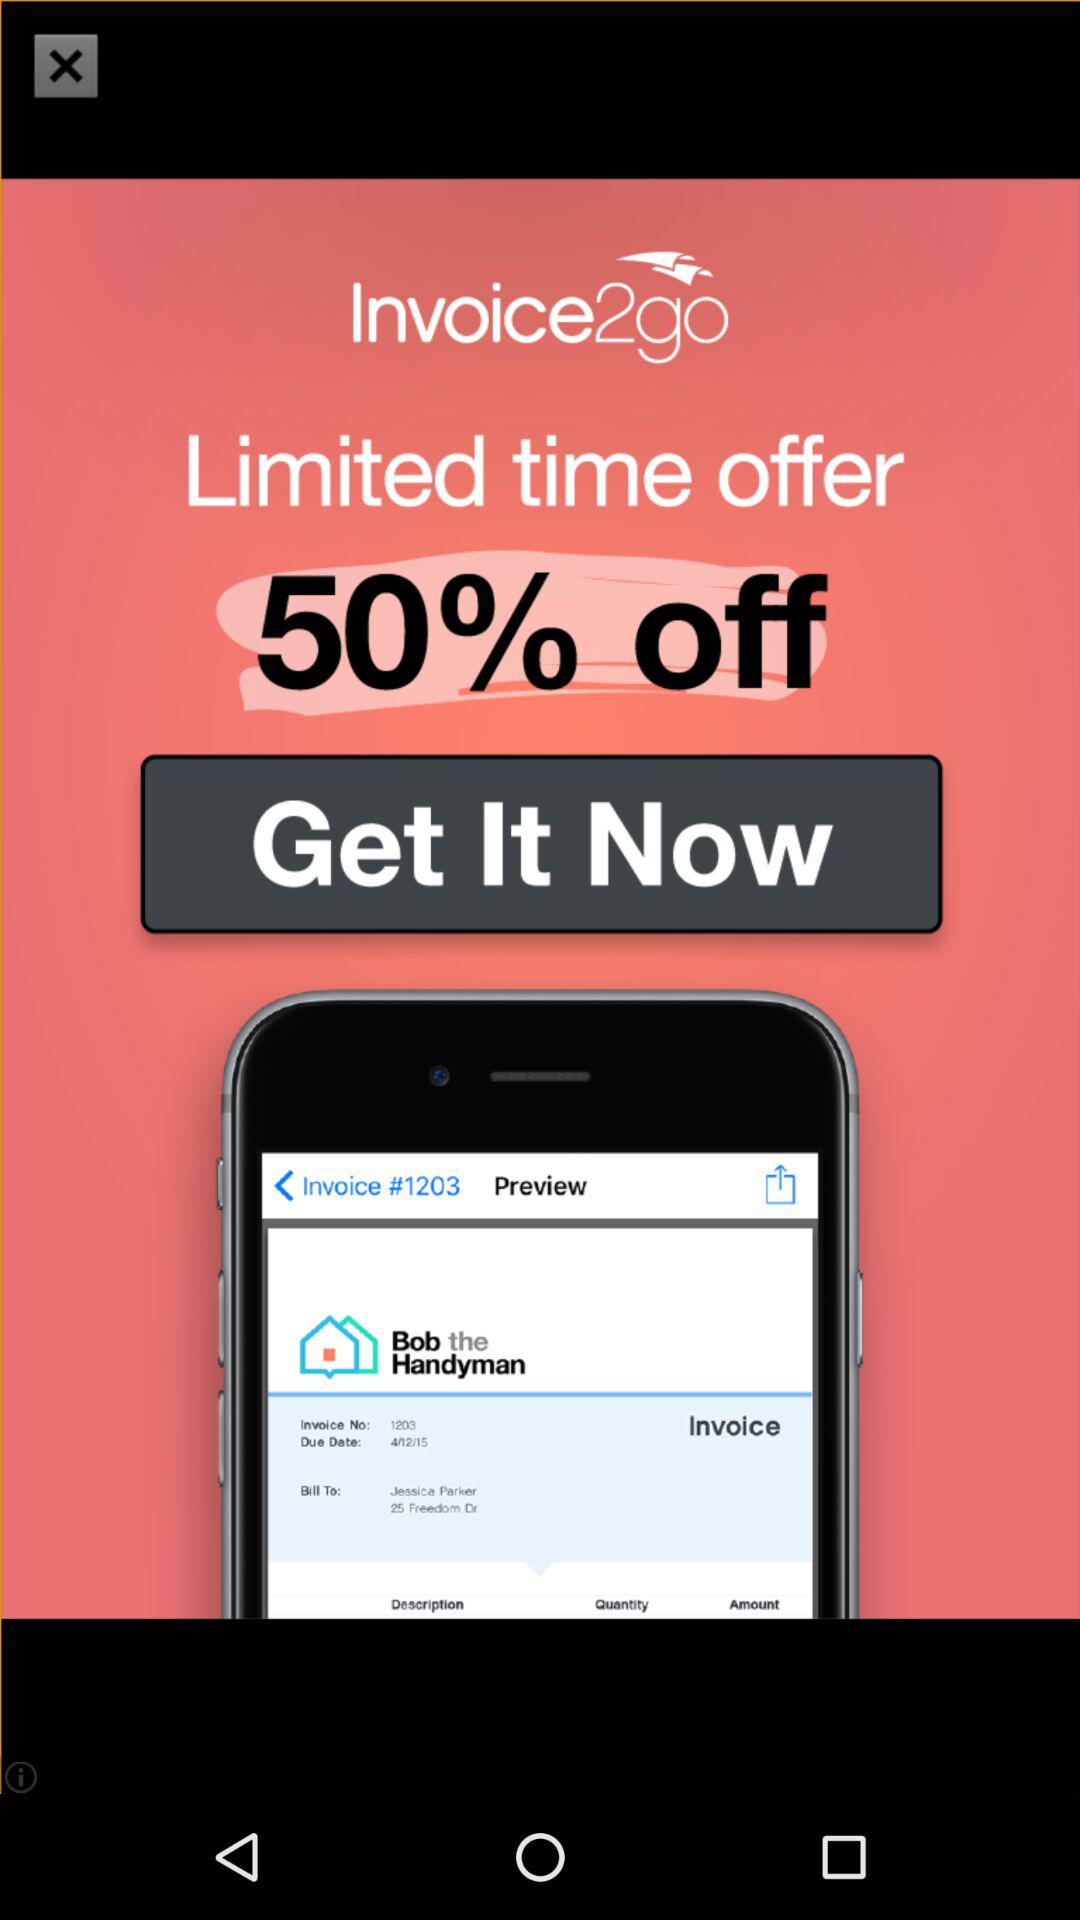What percentage is off? There is 50% off. 